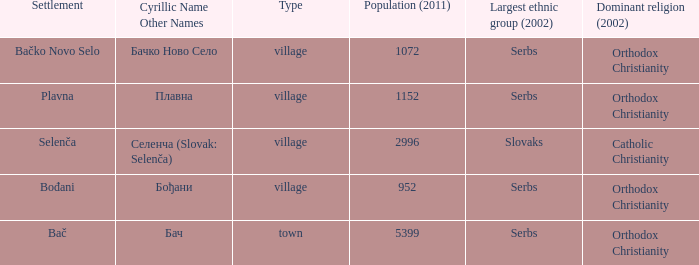What is the ethnic majority in the only town? Serbs. 